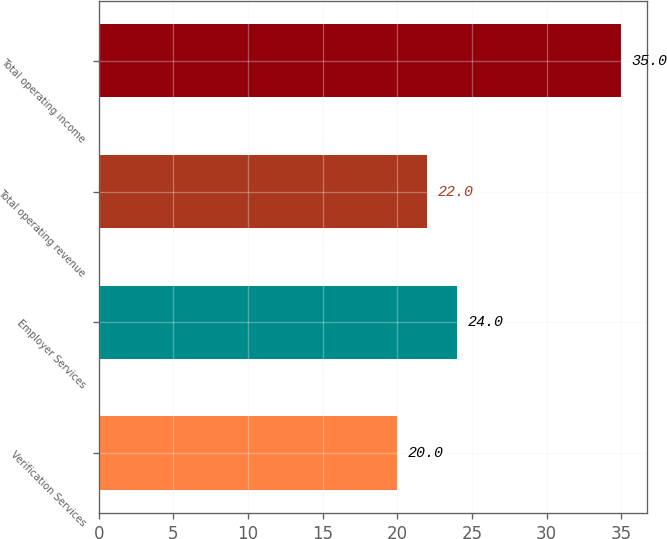<chart> <loc_0><loc_0><loc_500><loc_500><bar_chart><fcel>Verification Services<fcel>Employer Services<fcel>Total operating revenue<fcel>Total operating income<nl><fcel>20<fcel>24<fcel>22<fcel>35<nl></chart> 